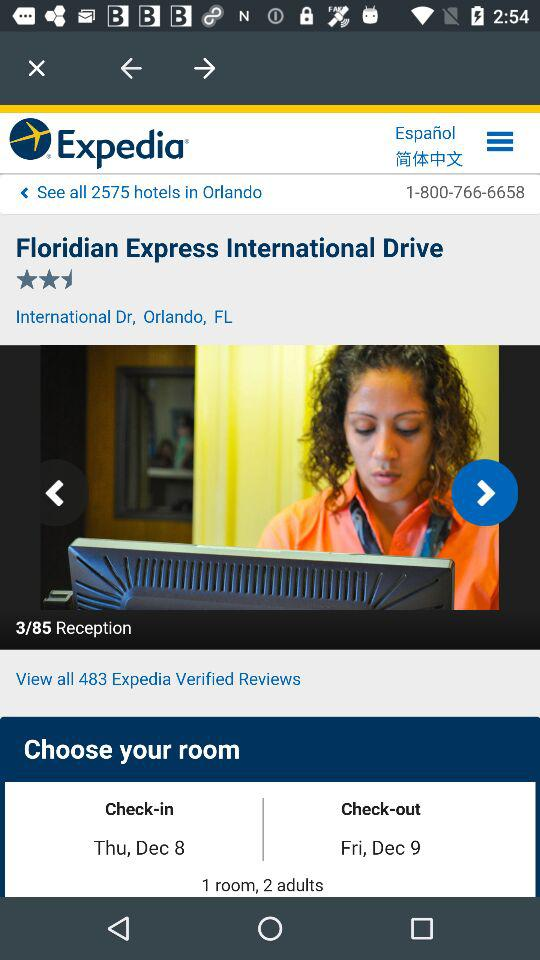What's the total number of adults? The total number of adults is 2. 